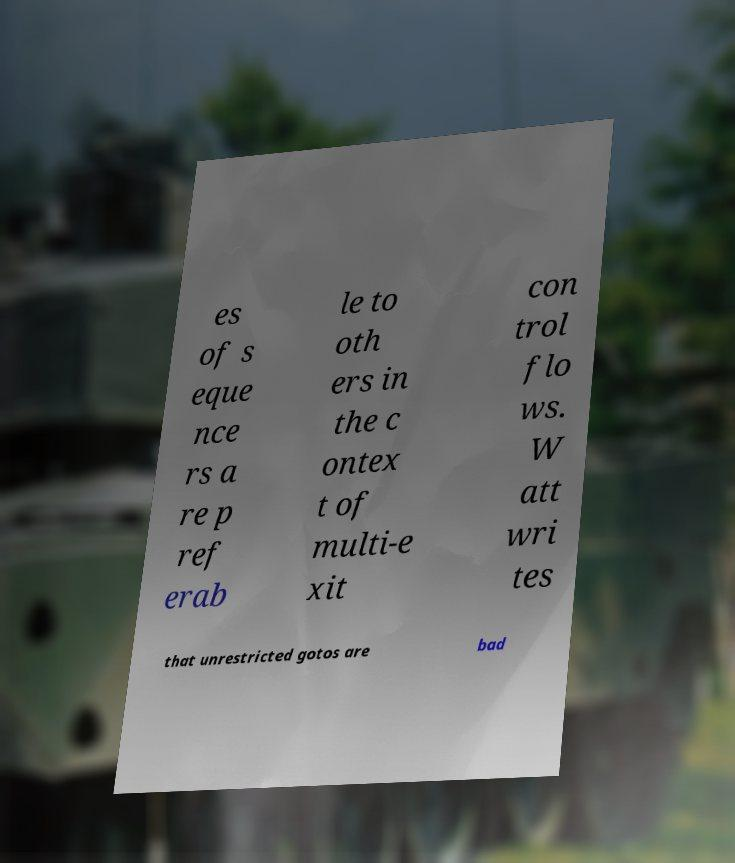Can you accurately transcribe the text from the provided image for me? es of s eque nce rs a re p ref erab le to oth ers in the c ontex t of multi-e xit con trol flo ws. W att wri tes that unrestricted gotos are bad 